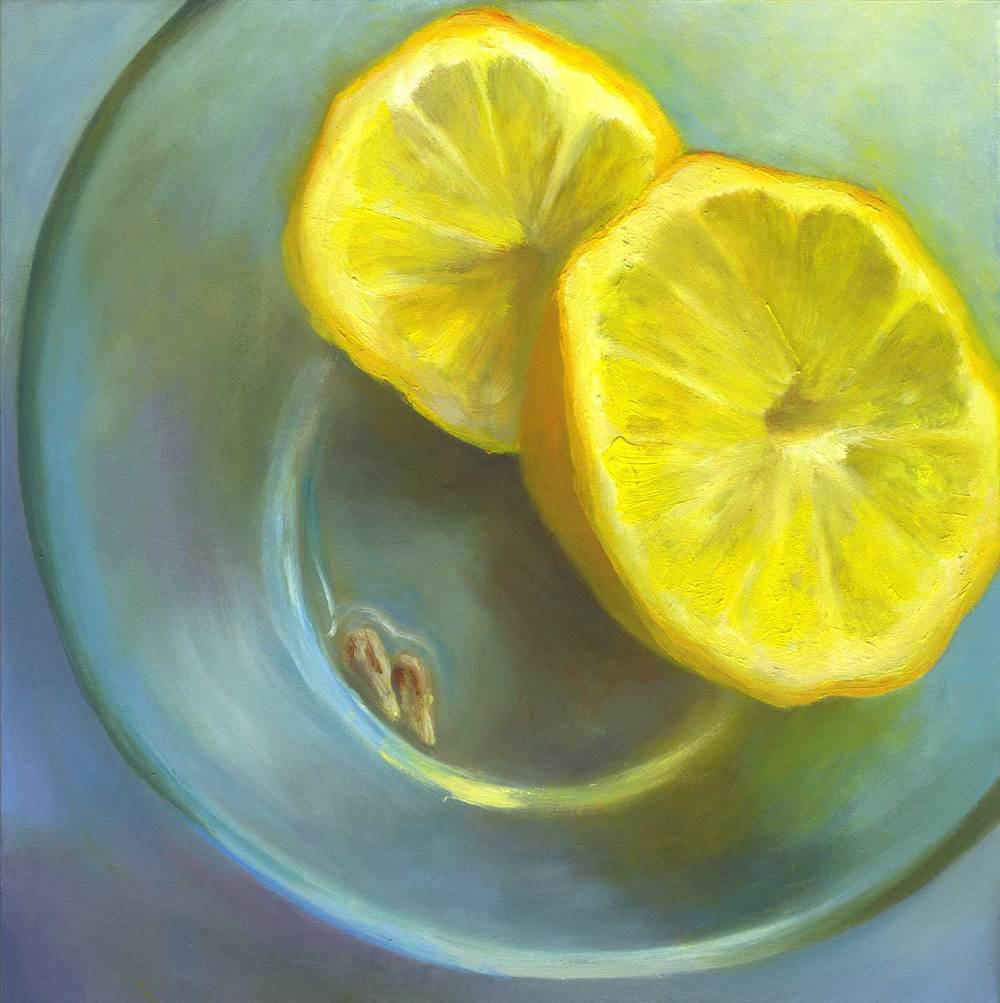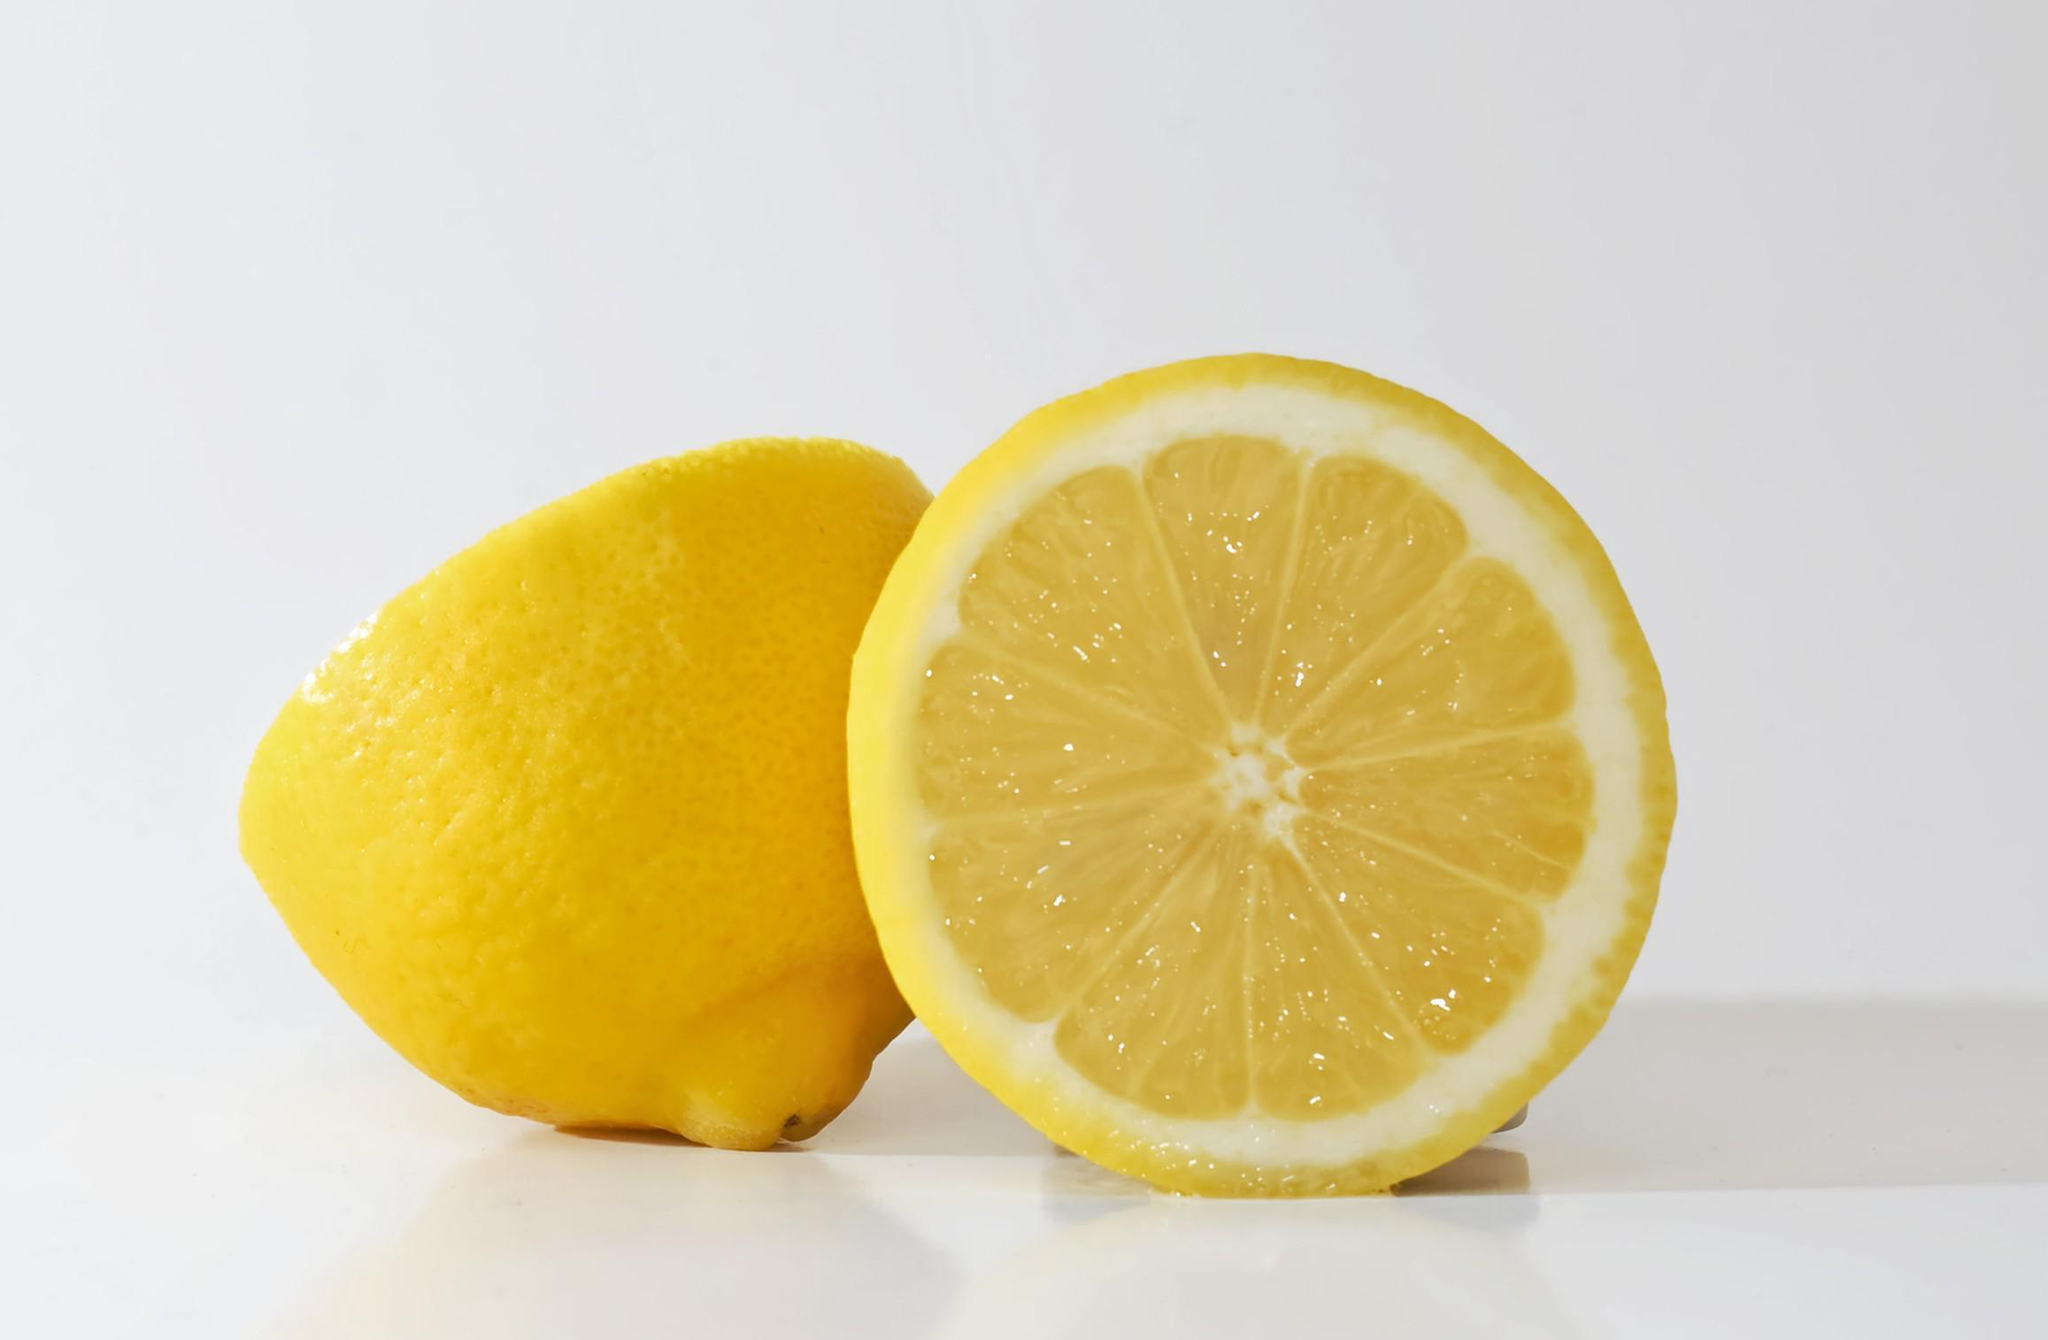The first image is the image on the left, the second image is the image on the right. For the images shown, is this caption "One image contains exactly two intact lemons, and the other includes a lemon half." true? Answer yes or no. No. The first image is the image on the left, the second image is the image on the right. Analyze the images presented: Is the assertion "The left image contains exactly two uncut lemons." valid? Answer yes or no. No. 